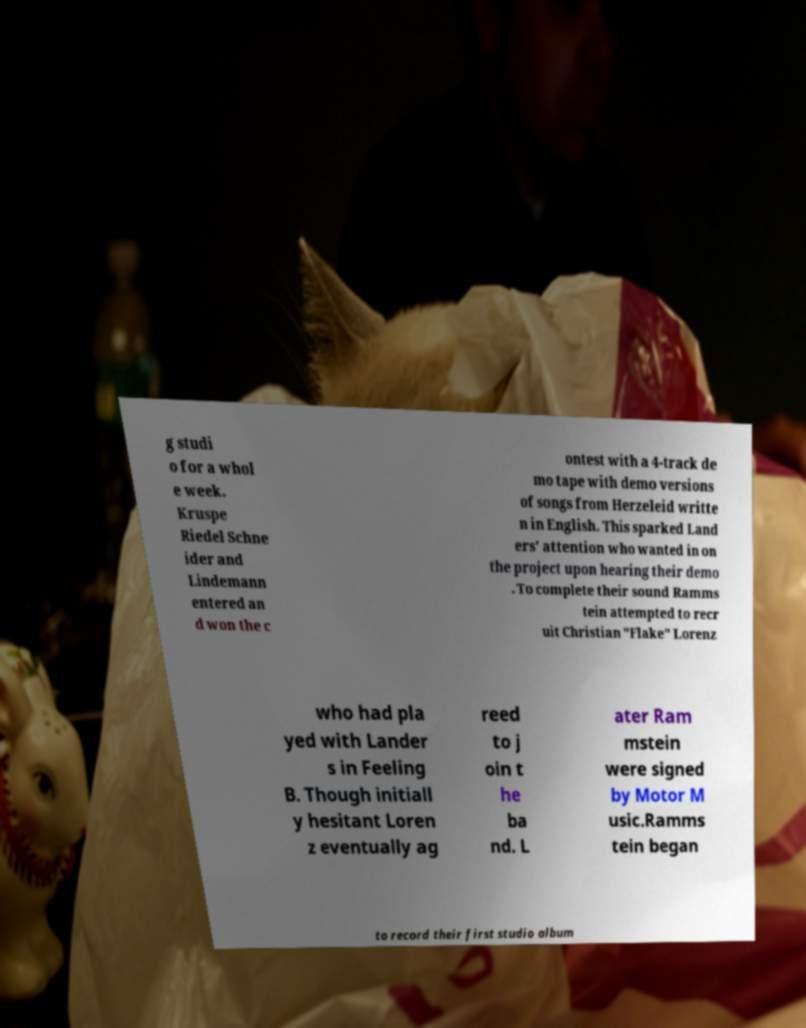For documentation purposes, I need the text within this image transcribed. Could you provide that? g studi o for a whol e week. Kruspe Riedel Schne ider and Lindemann entered an d won the c ontest with a 4-track de mo tape with demo versions of songs from Herzeleid writte n in English. This sparked Land ers' attention who wanted in on the project upon hearing their demo . To complete their sound Ramms tein attempted to recr uit Christian "Flake" Lorenz who had pla yed with Lander s in Feeling B. Though initiall y hesitant Loren z eventually ag reed to j oin t he ba nd. L ater Ram mstein were signed by Motor M usic.Ramms tein began to record their first studio album 